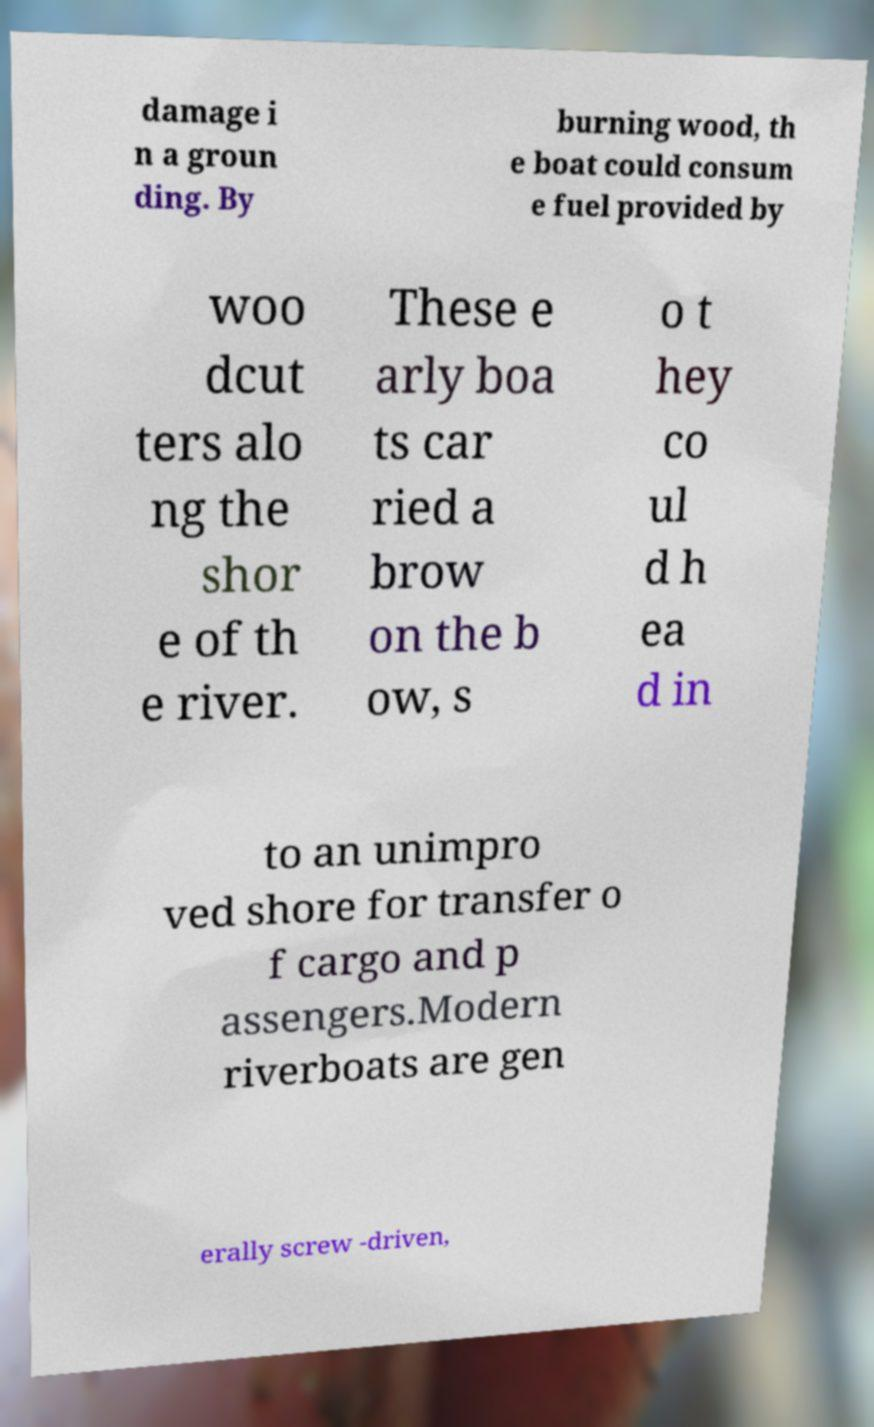Please identify and transcribe the text found in this image. damage i n a groun ding. By burning wood, th e boat could consum e fuel provided by woo dcut ters alo ng the shor e of th e river. These e arly boa ts car ried a brow on the b ow, s o t hey co ul d h ea d in to an unimpro ved shore for transfer o f cargo and p assengers.Modern riverboats are gen erally screw -driven, 